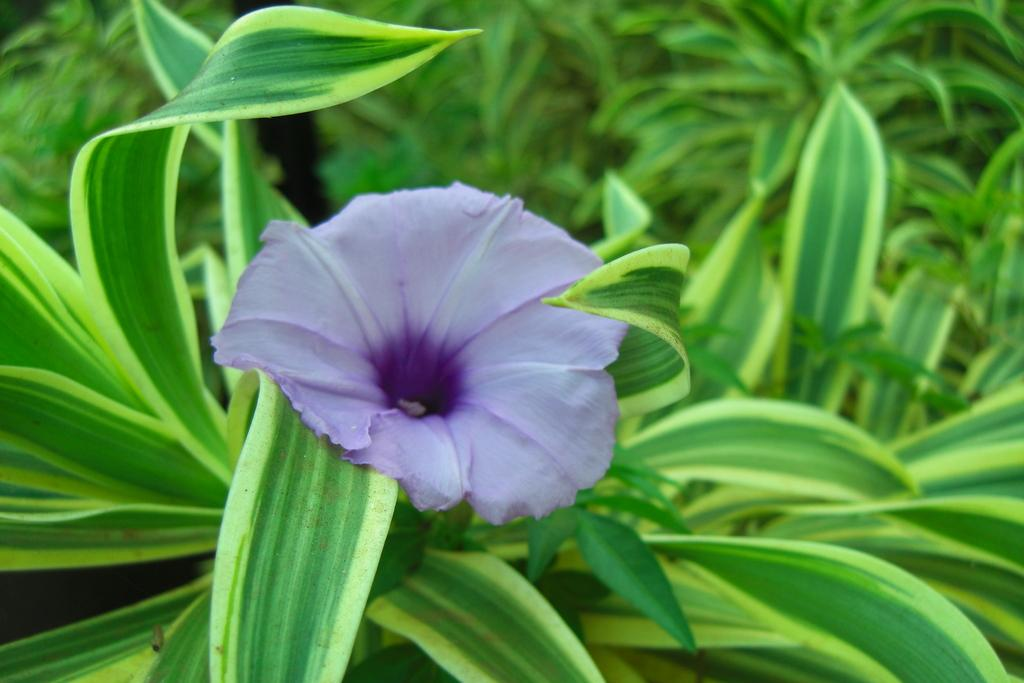What type of plant can be seen in the image? There is a flower in the image. What color are the leaves associated with the flower? There are green leaves in the image. What type of industry is depicted in the image? There is no industry present in the image; it features a flower and green leaves. How many people can be seen in the image? There are no people present in the image; it features a flower and green leaves. 